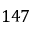<formula> <loc_0><loc_0><loc_500><loc_500>1 4 7</formula> 